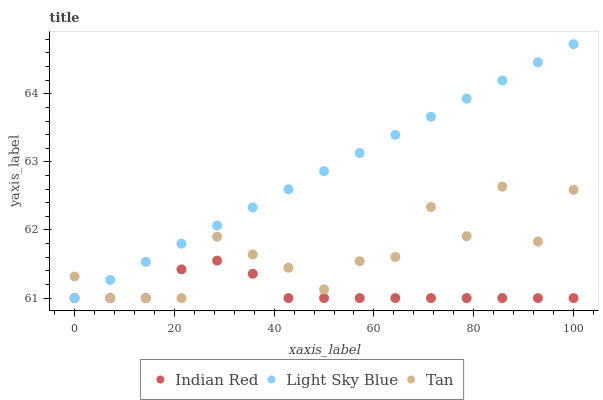Does Indian Red have the minimum area under the curve?
Answer yes or no. Yes. Does Light Sky Blue have the maximum area under the curve?
Answer yes or no. Yes. Does Light Sky Blue have the minimum area under the curve?
Answer yes or no. No. Does Indian Red have the maximum area under the curve?
Answer yes or no. No. Is Light Sky Blue the smoothest?
Answer yes or no. Yes. Is Tan the roughest?
Answer yes or no. Yes. Is Indian Red the smoothest?
Answer yes or no. No. Is Indian Red the roughest?
Answer yes or no. No. Does Tan have the lowest value?
Answer yes or no. Yes. Does Light Sky Blue have the highest value?
Answer yes or no. Yes. Does Indian Red have the highest value?
Answer yes or no. No. Does Light Sky Blue intersect Tan?
Answer yes or no. Yes. Is Light Sky Blue less than Tan?
Answer yes or no. No. Is Light Sky Blue greater than Tan?
Answer yes or no. No. 